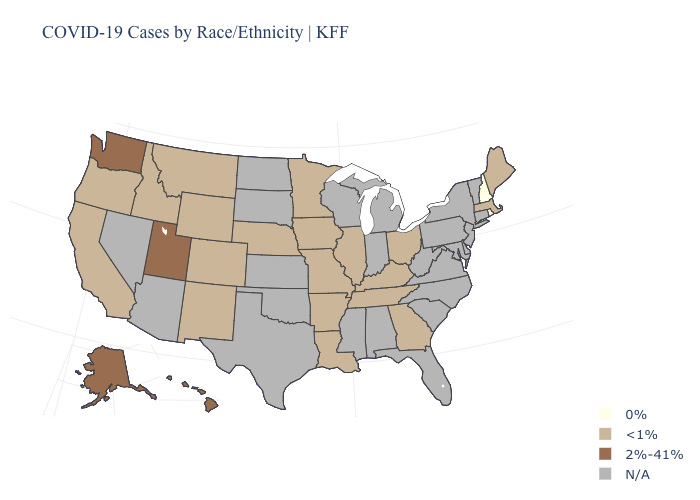What is the lowest value in states that border Nevada?
Answer briefly. <1%. What is the value of North Carolina?
Write a very short answer. N/A. Name the states that have a value in the range N/A?
Be succinct. Alabama, Arizona, Connecticut, Delaware, Florida, Indiana, Kansas, Maryland, Michigan, Mississippi, Nevada, New Jersey, New York, North Carolina, North Dakota, Oklahoma, Pennsylvania, South Carolina, South Dakota, Texas, Vermont, Virginia, West Virginia, Wisconsin. Does Louisiana have the highest value in the USA?
Write a very short answer. No. Does the map have missing data?
Be succinct. Yes. What is the highest value in the USA?
Be succinct. 2%-41%. Name the states that have a value in the range <1%?
Be succinct. Arkansas, California, Colorado, Georgia, Idaho, Illinois, Iowa, Kentucky, Louisiana, Maine, Massachusetts, Minnesota, Missouri, Montana, Nebraska, New Mexico, Ohio, Oregon, Tennessee, Wyoming. What is the lowest value in the USA?
Keep it brief. 0%. Does the first symbol in the legend represent the smallest category?
Concise answer only. Yes. What is the value of Hawaii?
Write a very short answer. 2%-41%. Name the states that have a value in the range 2%-41%?
Give a very brief answer. Alaska, Hawaii, Utah, Washington. Does the first symbol in the legend represent the smallest category?
Quick response, please. Yes. 